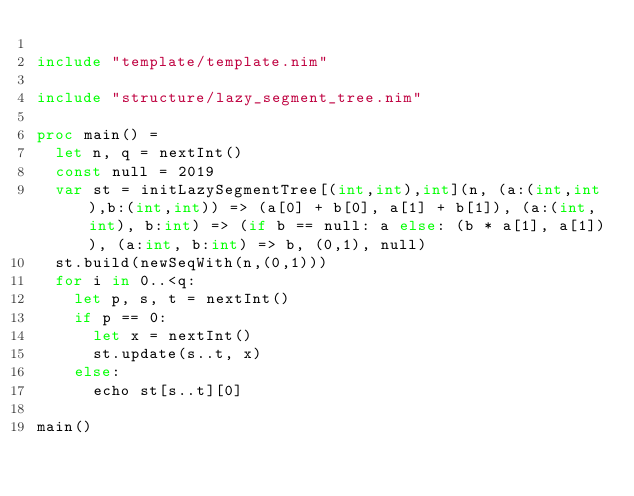Convert code to text. <code><loc_0><loc_0><loc_500><loc_500><_Nim_>
include "template/template.nim"

include "structure/lazy_segment_tree.nim"

proc main() =
  let n, q = nextInt()
  const null = 2019
  var st = initLazySegmentTree[(int,int),int](n, (a:(int,int),b:(int,int)) => (a[0] + b[0], a[1] + b[1]), (a:(int,int), b:int) => (if b == null: a else: (b * a[1], a[1])), (a:int, b:int) => b, (0,1), null)
  st.build(newSeqWith(n,(0,1)))
  for i in 0..<q:
    let p, s, t = nextInt()
    if p == 0:
      let x = nextInt()
      st.update(s..t, x)
    else:
      echo st[s..t][0]

main()
</code> 